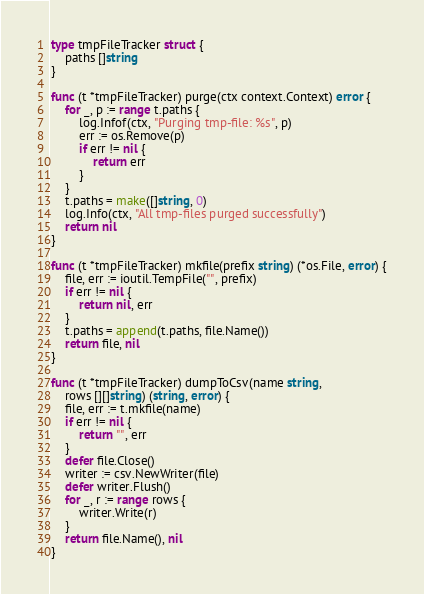<code> <loc_0><loc_0><loc_500><loc_500><_Go_>type tmpFileTracker struct {
	paths []string
}

func (t *tmpFileTracker) purge(ctx context.Context) error {
	for _, p := range t.paths {
		log.Infof(ctx, "Purging tmp-file: %s", p)
		err := os.Remove(p)
		if err != nil {
			return err
		}
	}
	t.paths = make([]string, 0)
	log.Info(ctx, "All tmp-files purged successfully")
	return nil
}

func (t *tmpFileTracker) mkfile(prefix string) (*os.File, error) {
	file, err := ioutil.TempFile("", prefix)
	if err != nil {
		return nil, err
	}
	t.paths = append(t.paths, file.Name())
	return file, nil
}

func (t *tmpFileTracker) dumpToCsv(name string,
	rows [][]string) (string, error) {
	file, err := t.mkfile(name)
	if err != nil {
		return "", err
	}
	defer file.Close()
	writer := csv.NewWriter(file)
	defer writer.Flush()
	for _, r := range rows {
		writer.Write(r)
	}
	return file.Name(), nil
}
</code> 